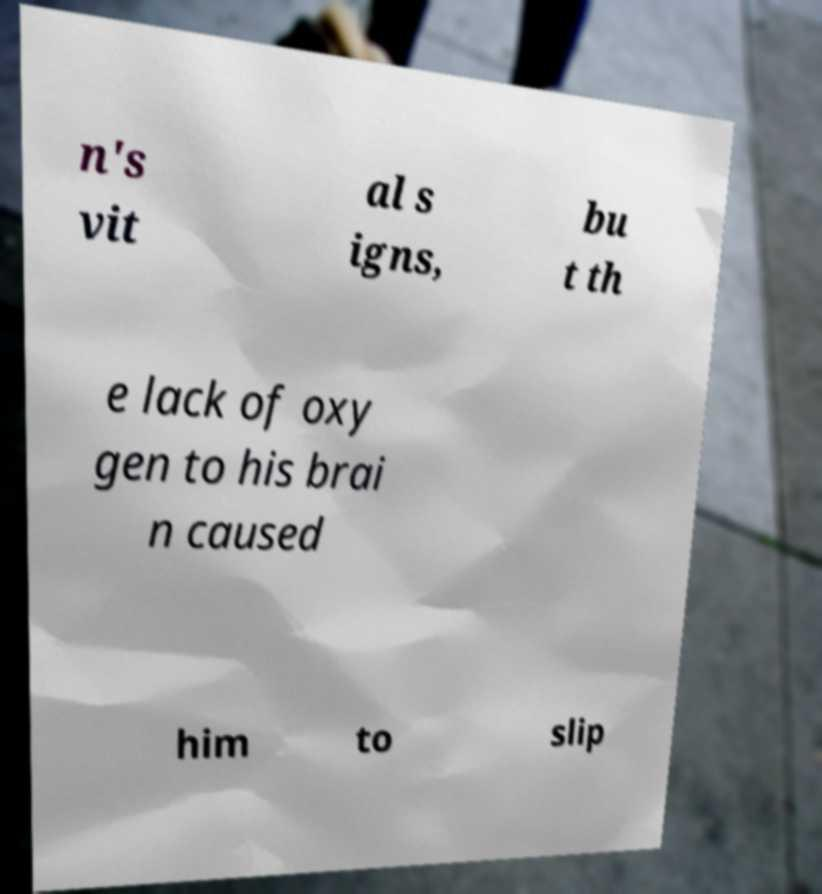What messages or text are displayed in this image? I need them in a readable, typed format. n's vit al s igns, bu t th e lack of oxy gen to his brai n caused him to slip 